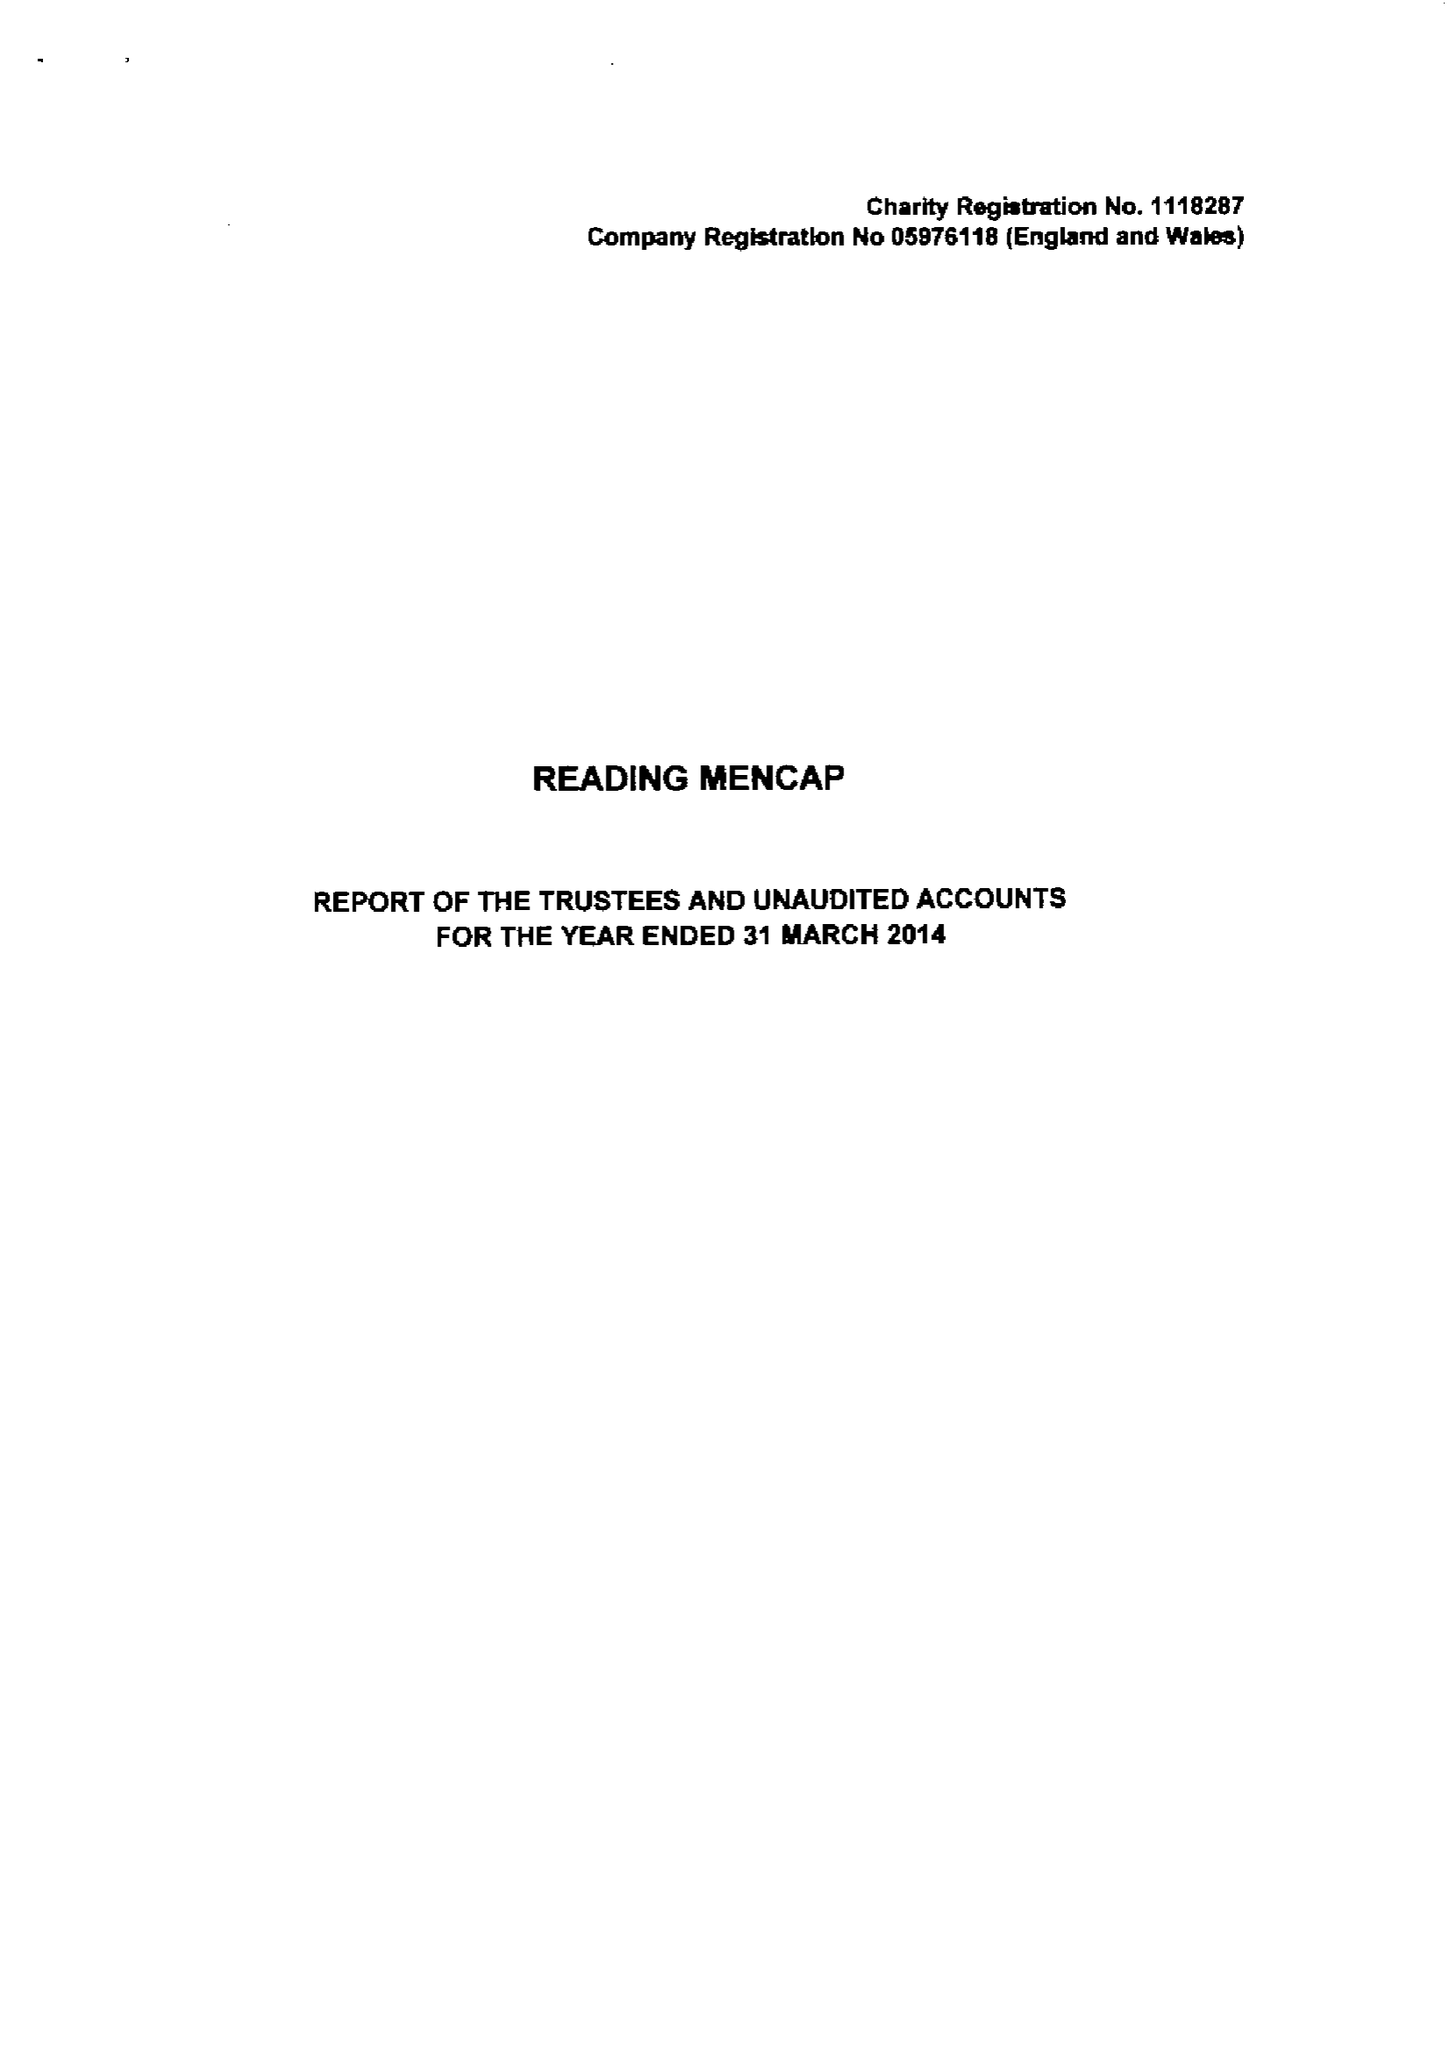What is the value for the spending_annually_in_british_pounds?
Answer the question using a single word or phrase. 201166.00 